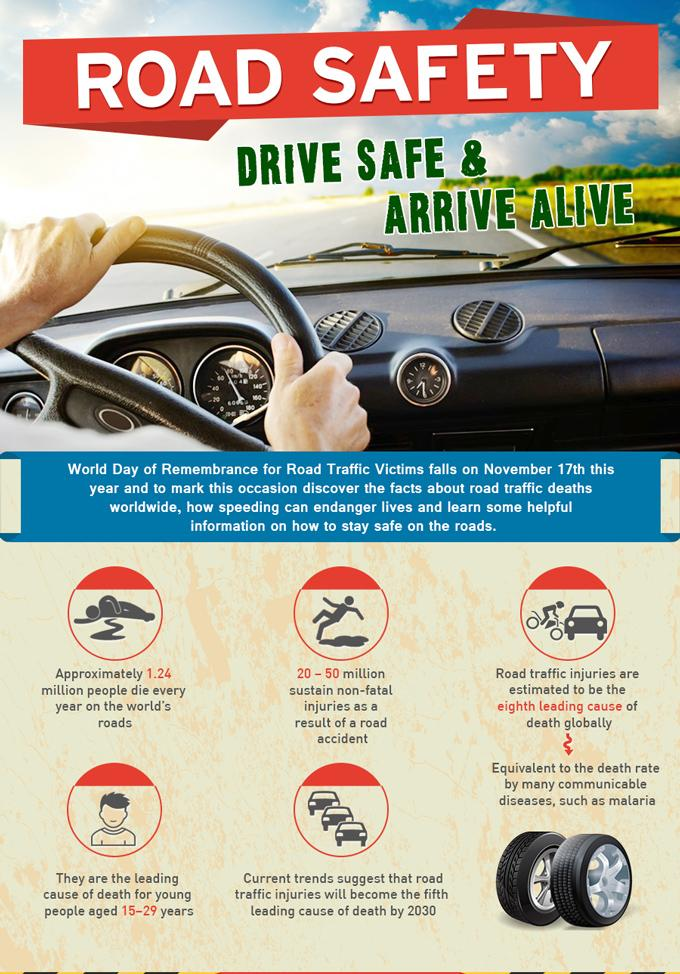List a handful of essential elements in this visual. Communicable diseases, specifically malaria, are the eighth leading cause of death globally, other than road traffic injuries. In young people aged 15-29 years, road traffic injuries are the leading cause of death. 